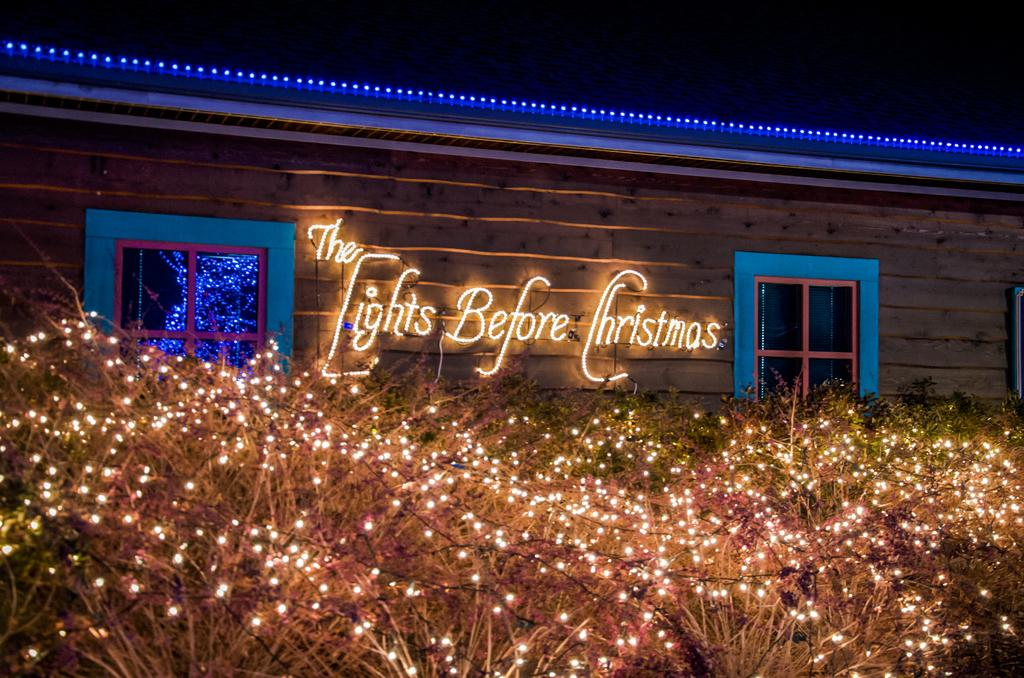What type of decoration is present on the plants in the image? There are decorative lights on the plants in the image. Where else can we find decorative lights in the image? Decorative lights are also present on the roof. What architectural feature is visible in the image? Windows are visible in the image. What type of message is conveyed using lights in the image? Texts written with lights are present on the wall. How would you describe the lighting conditions in the top part of the image? The top part of the image is dark. How many clocks are visible in the image? There are no clocks present in the image. What type of grip is required to handle the bomb in the image? There is no bomb present in the image, so the question of grip is not applicable. 